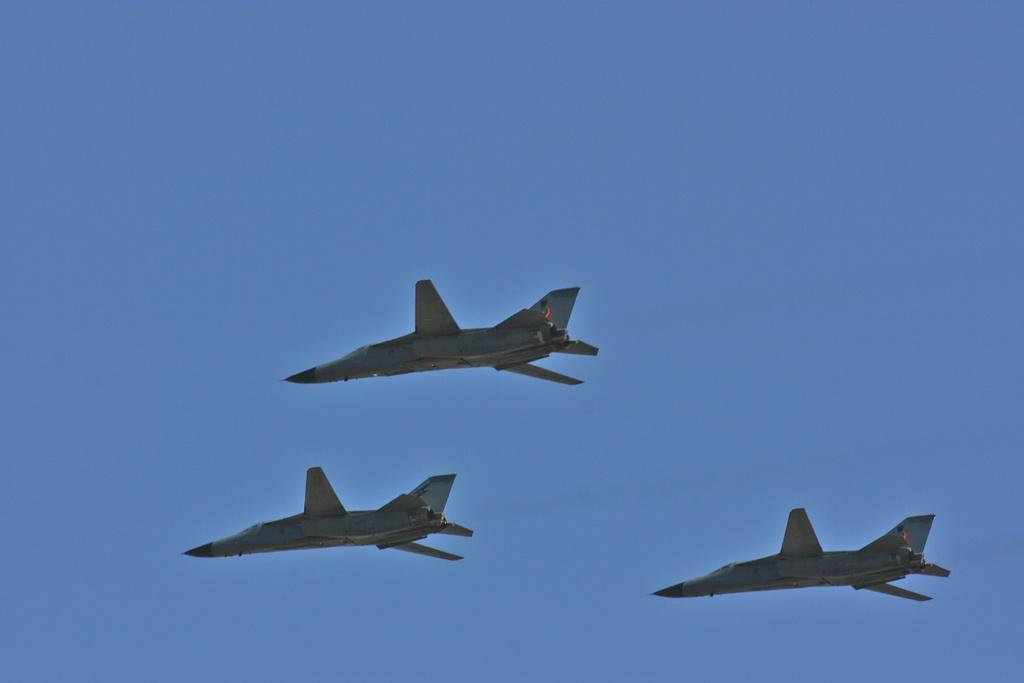What is the main subject of the image? The main subject of the image is three aircraft. Can you describe the background of the image? The background of the image is blue. How many bubbles can be seen around the aircraft in the image? There are no bubbles present in the image. What type of trees are visible in the background of the image? There are no trees visible in the image; the background is blue. 